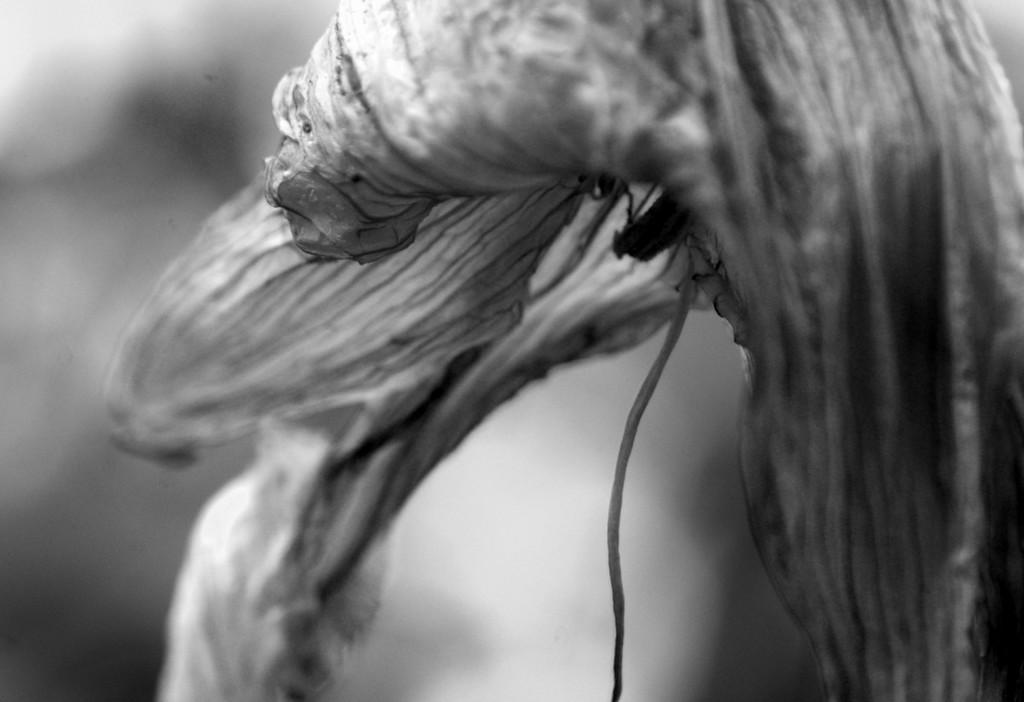What is the color scheme of the image? The image is black and white. What type of creature can be seen in the image? There is an insect in the image. What plant is present in the image? There is a flower in the image. How would you describe the background of the image? The background of the image is blurry. What type of credit card is visible in the image? There is no credit card present in the image; it features an insect and a flower. Can you tell me the color of the father's lip in the image? There is no father or lip present in the image; it is a black and white image of an insect and a flower. 